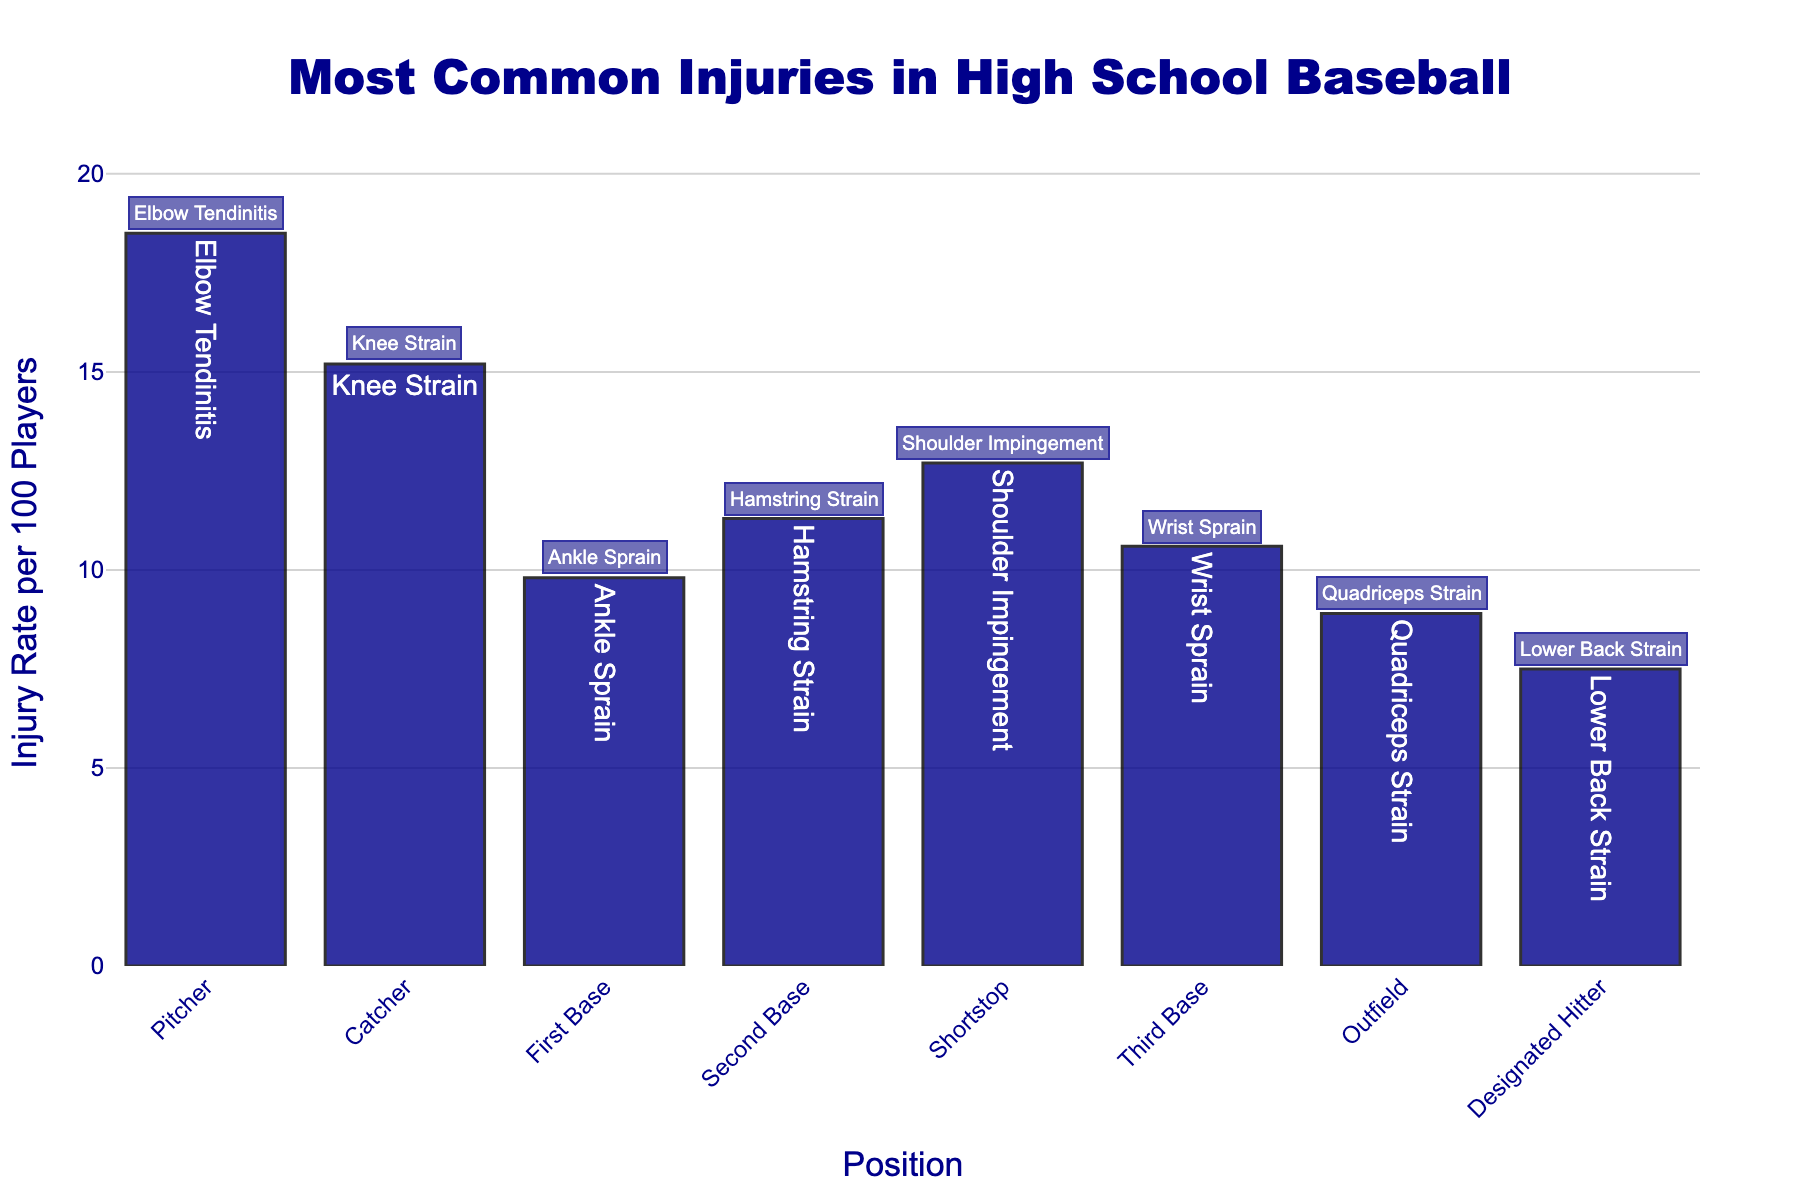What is the most common injury for pitchers? The bar for pitchers indicates that the most common injury for this position is "Elbow Tendinitis," as noted in the text label on the bar.
Answer: Elbow Tendinitis Which position has the highest injury rate per 100 players? By comparing the heights of the bars, the pitcher position has the highest bar, indicating the highest injury rate per 100 players, which is 18.5.
Answer: Pitcher What is the injury rate difference between catchers and designated hitters? The injury rate for catchers is 15.2, and for designated hitters, it is 7.5. The difference is calculated as 15.2 - 7.5.
Answer: 7.7 How many positions have an injury rate higher than 10 per 100 players? By evaluating the bars that extend above the 10 mark on the y-axis, the positions exceeding this threshold are pitcher, catcher, second base, shortstop, and third base.
Answer: 5 Which position has the lowest injury rate, and what is this rate? The shortest bar corresponds to the designated hitter position, indicating the lowest injury rate of 7.5 per 100 players.
Answer: Designated Hitter, 7.5 What is the total injury rate per 100 players for the infield positions (first, second, shortstop, third base)? Summing the injury rates for the infield positions: 9.8 (first base) + 11.3 (second base) + 12.7 (shortstop) + 10.6 (third base) equals 44.4.
Answer: 44.4 Does the outfield position have a higher or lower injury rate than the shortstop position? Comparing the heights of the bars, the shortstop injury rate (12.7) is higher than the outfield injury rate (8.9).
Answer: Lower What injury is most common for the third base position? According to the text label on the bar for third base, the most common injury is "Wrist Sprain."
Answer: Wrist Sprain What is the average injury rate per 100 players for all positions? Sum the injury rates and divide by the number of positions: (18.5 + 15.2 + 9.8 + 11.3 + 12.7 + 10.6 + 8.9 + 7.5) / 8 = 11.81
Answer: 11.81 Which two positions have the closest injury rates per 100 players? By comparing the values, second base and third base have the closest rates: 11.3 and 10.6, respectively. The difference is 0.7.
Answer: Second Base and Third Base 